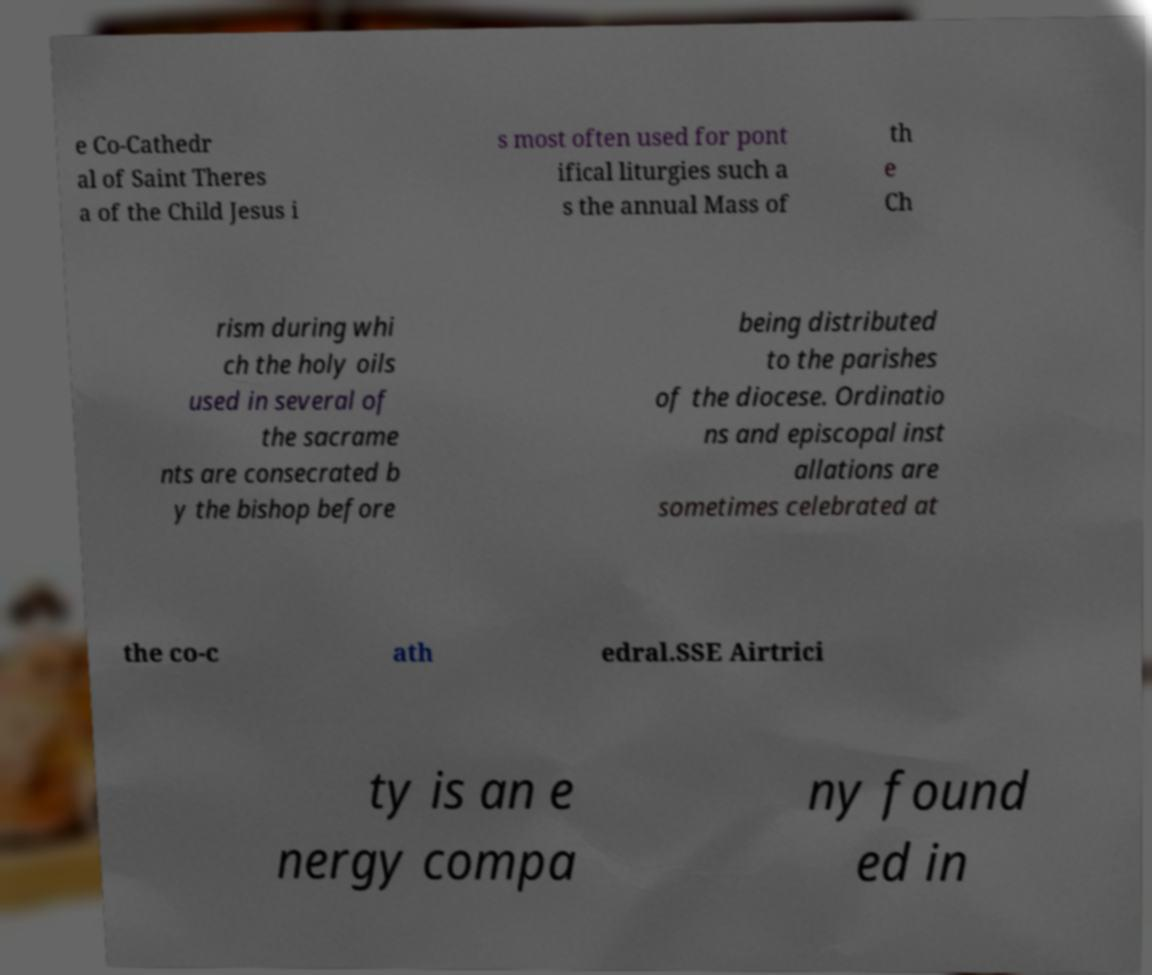Can you accurately transcribe the text from the provided image for me? e Co-Cathedr al of Saint Theres a of the Child Jesus i s most often used for pont ifical liturgies such a s the annual Mass of th e Ch rism during whi ch the holy oils used in several of the sacrame nts are consecrated b y the bishop before being distributed to the parishes of the diocese. Ordinatio ns and episcopal inst allations are sometimes celebrated at the co-c ath edral.SSE Airtrici ty is an e nergy compa ny found ed in 